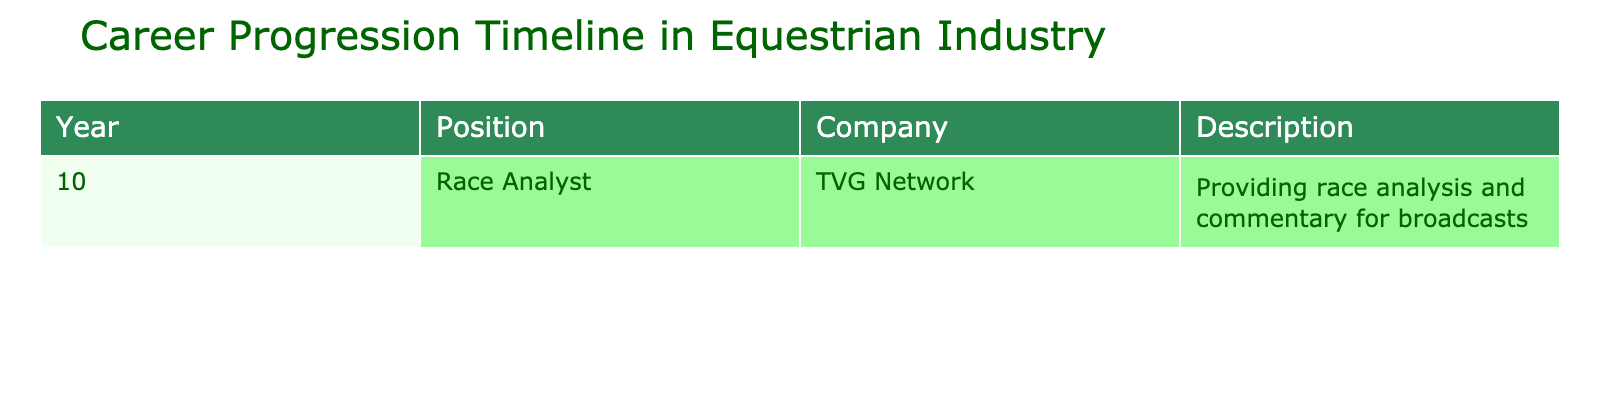What position is listed for the year 10? The table shows that in year 10, the position listed is "Race Analyst."
Answer: Race Analyst Which company employed the individual in the year 10? According to the table, the company that employed the individual in year 10 is "TVG Network."
Answer: TVG Network What type of work did the Race Analyst do? The description in the table indicates that the Race Analyst provided race analysis and commentary for broadcasts.
Answer: Provided race analysis and commentary for broadcasts Is there a position listed prior to year 10? The table only contains data for year 10 and does not list any positions for earlier years. Therefore, there are no positions prior to year 10.
Answer: No What is the nature of the work described for the Race Analyst role? The description states that the Race Analyst's work involves analyzing races and providing commentary during broadcasts, which means the role focuses on both analytical and communicative skills in the context of horse racing.
Answer: Analytic and communicative skills in horse racing If someone wanted to pursue a similar career, what company should they consider based on this table? Based on the table, a good company to consider for a career in this field would be TVG Network, as they hired a Race Analyst.
Answer: TVG Network What category of positions is the "Race Analyst" role classified under? The "Race Analyst" role would be classified as an entry-level position in the equestrian industry according to the table's context.
Answer: Entry-level position In what year do the data show the first recorded position? The only year listed in the table is year 10, which is the first and only record provided.
Answer: Year 10 